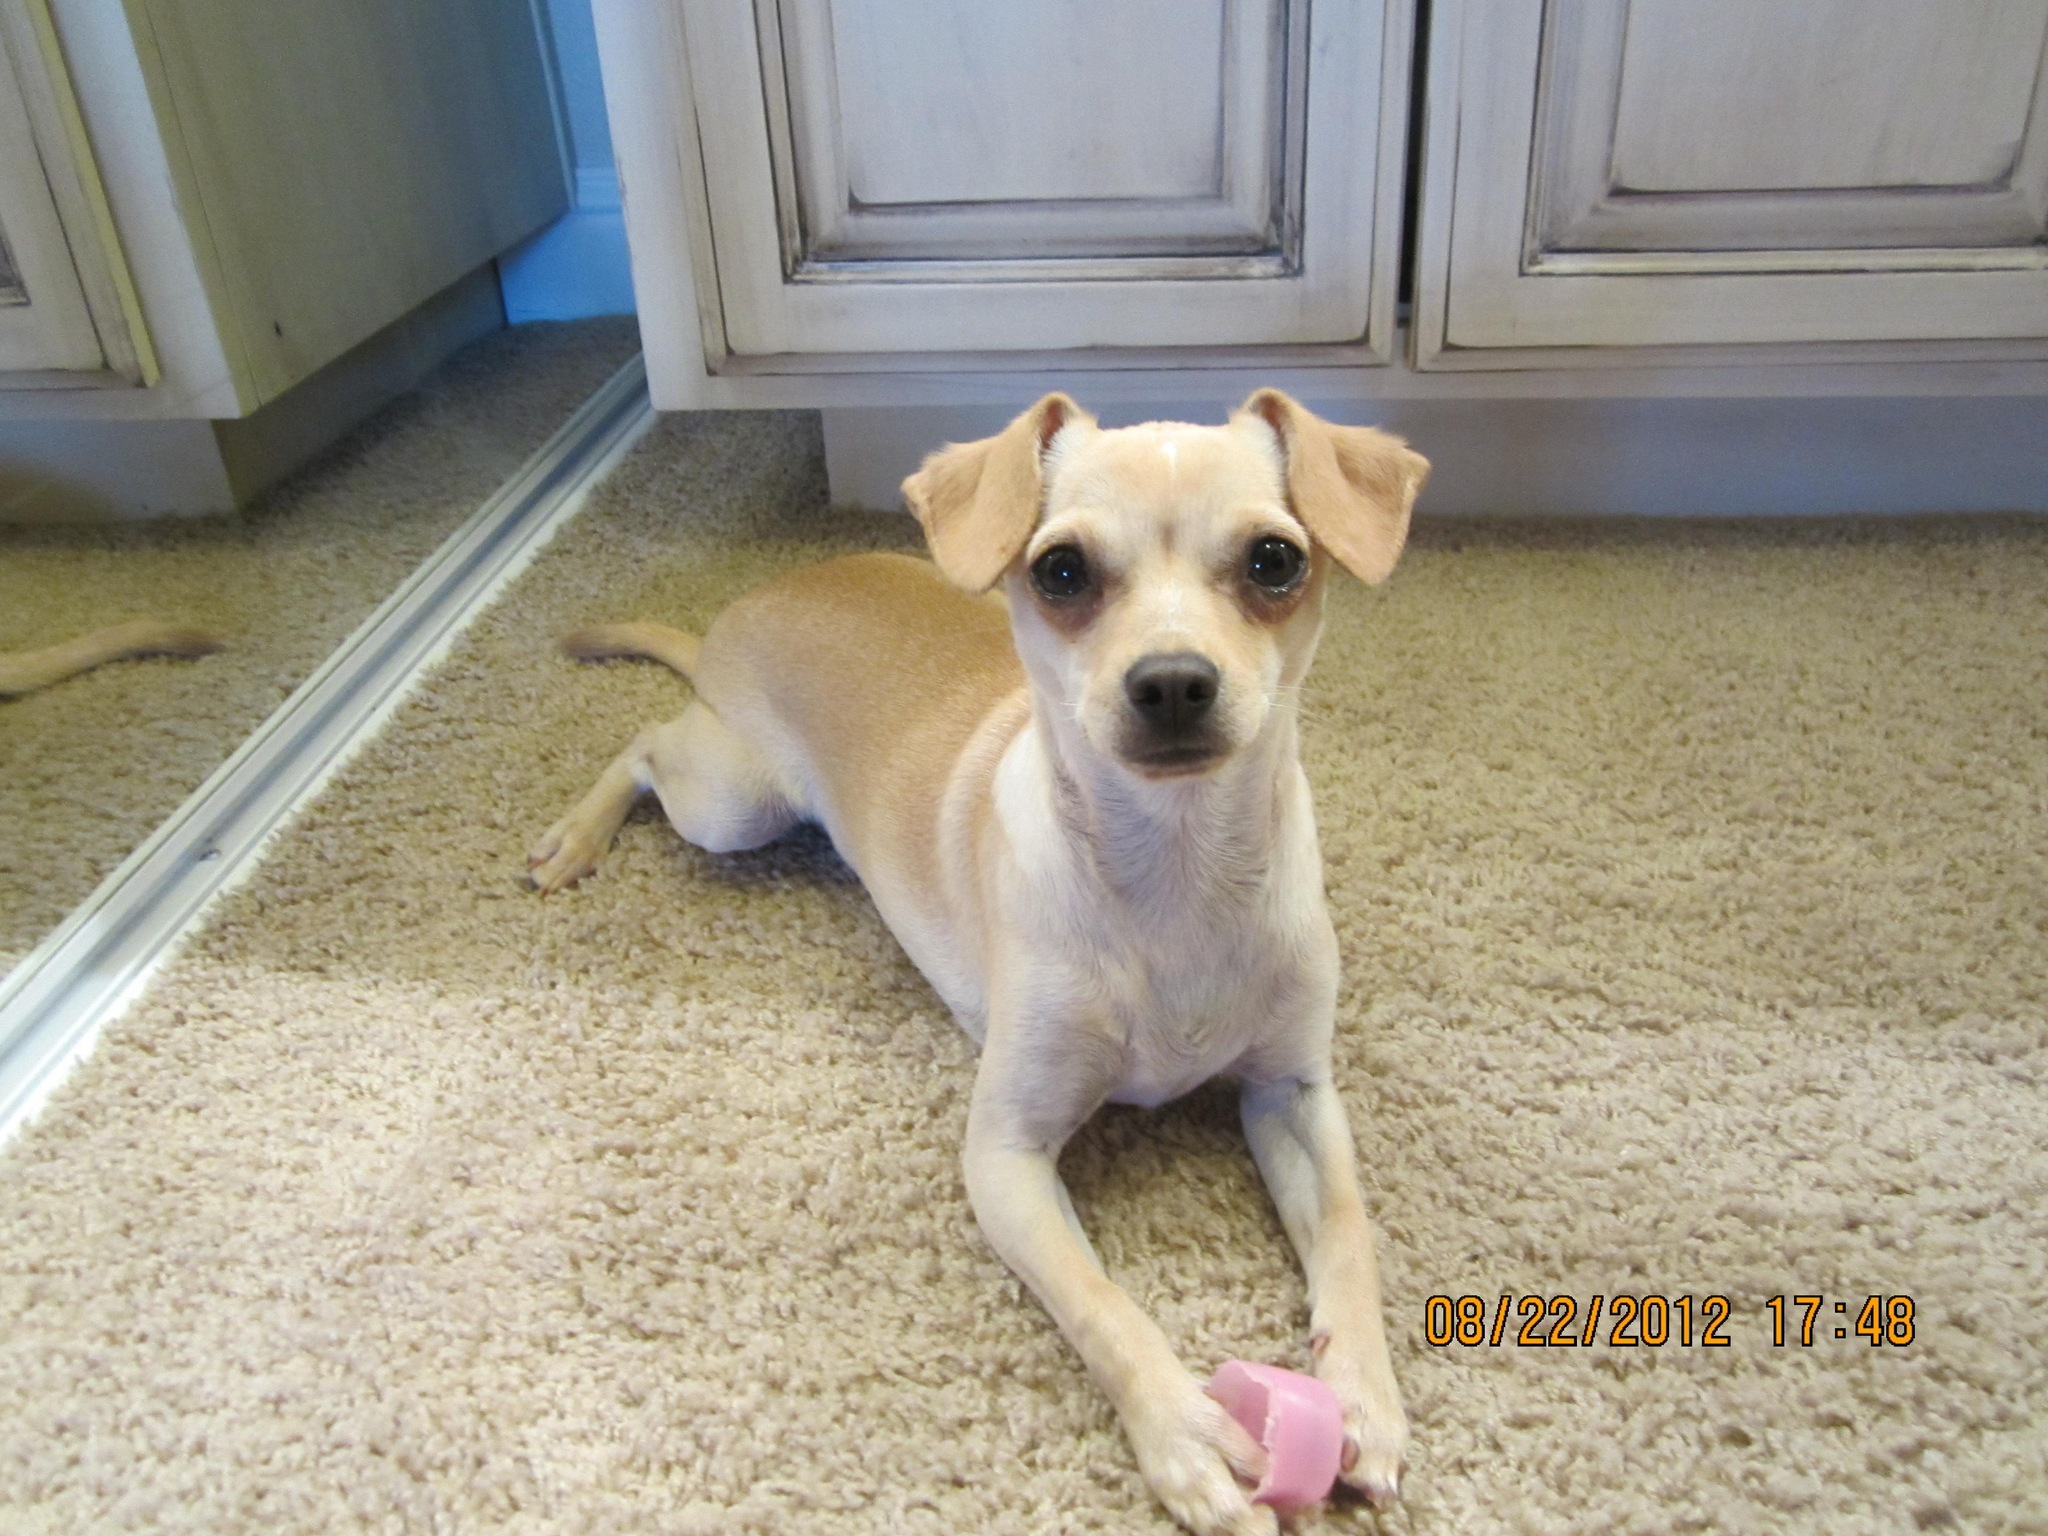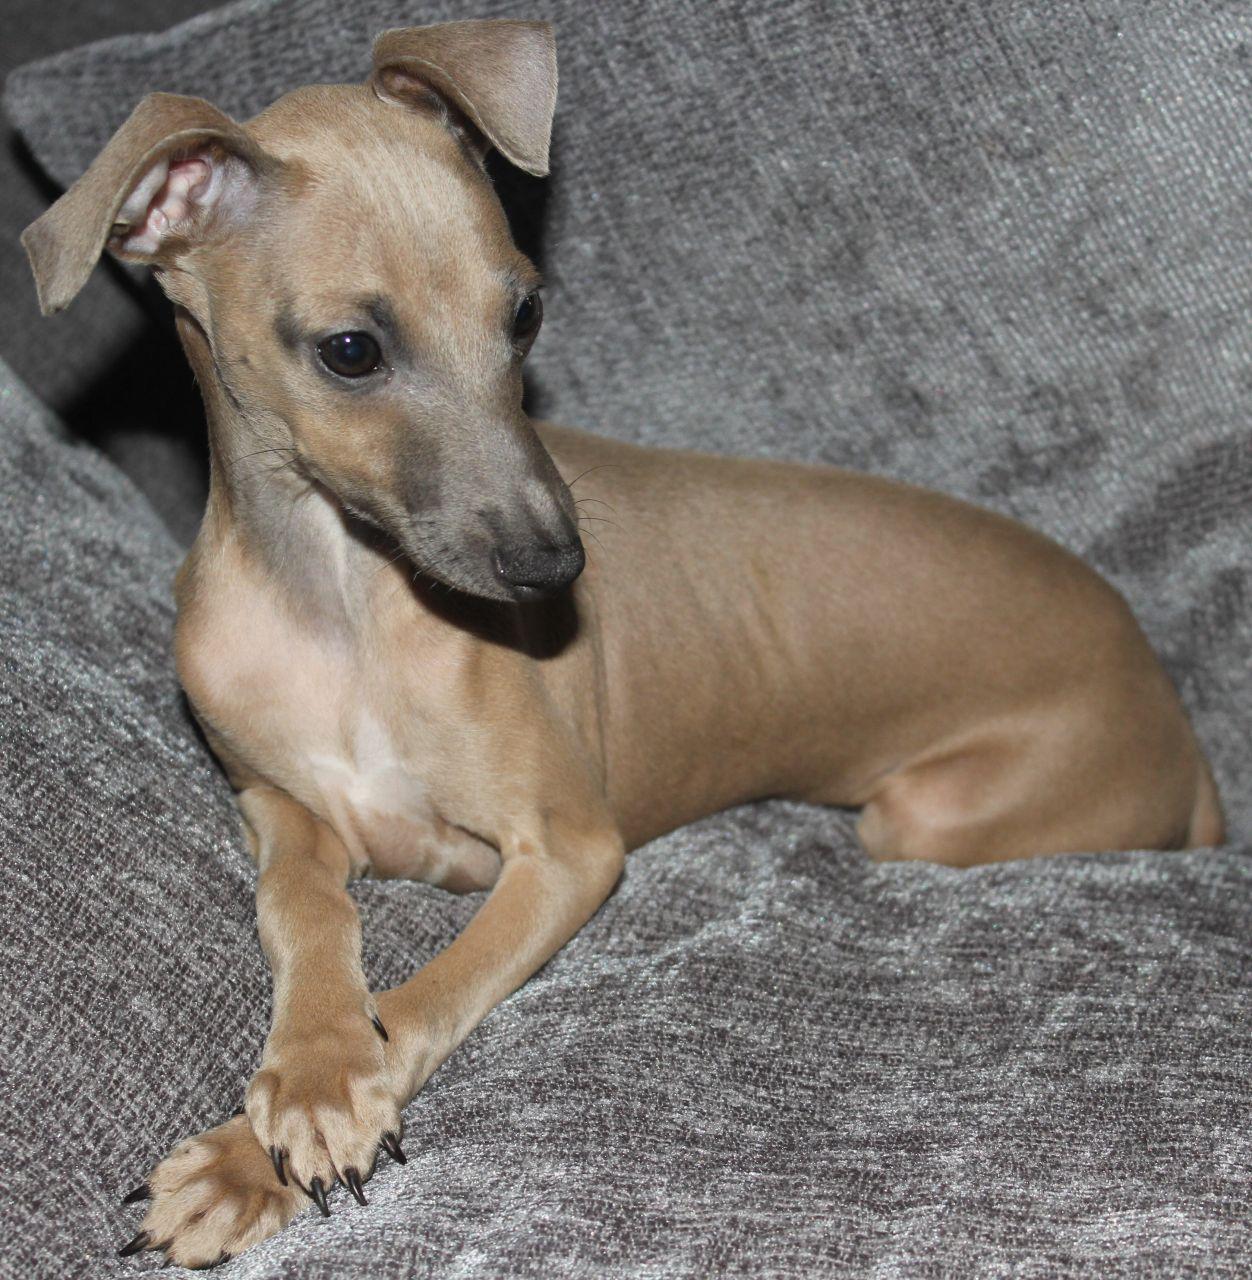The first image is the image on the left, the second image is the image on the right. Analyze the images presented: Is the assertion "In one of the images the dog is on a tile floor." valid? Answer yes or no. No. The first image is the image on the left, the second image is the image on the right. Given the left and right images, does the statement "Each image shows exactly one non-standing hound, and the combined images show at least one hound reclining with front paws extended in front of its body." hold true? Answer yes or no. Yes. 